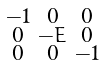Convert formula to latex. <formula><loc_0><loc_0><loc_500><loc_500>\begin{smallmatrix} - 1 & 0 & 0 \\ 0 & - E & 0 \\ 0 & 0 & - 1 \end{smallmatrix}</formula> 